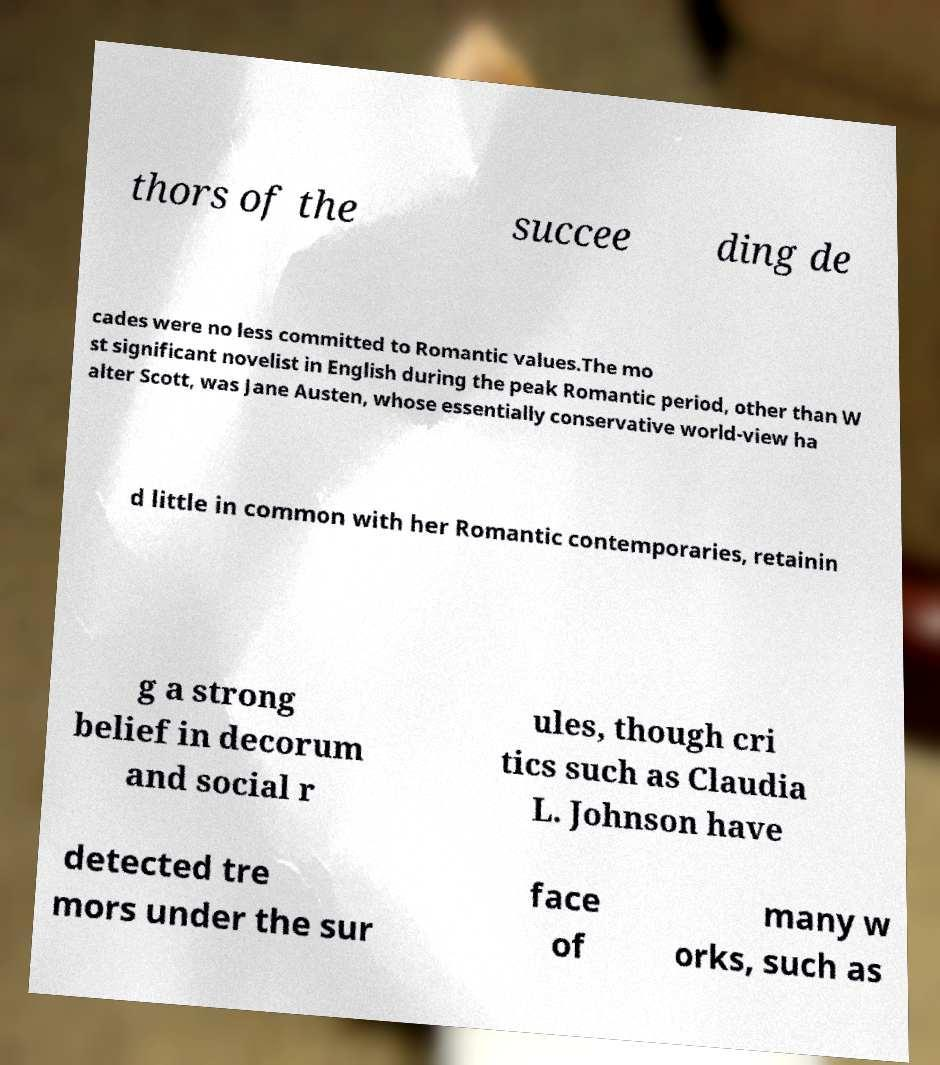There's text embedded in this image that I need extracted. Can you transcribe it verbatim? thors of the succee ding de cades were no less committed to Romantic values.The mo st significant novelist in English during the peak Romantic period, other than W alter Scott, was Jane Austen, whose essentially conservative world-view ha d little in common with her Romantic contemporaries, retainin g a strong belief in decorum and social r ules, though cri tics such as Claudia L. Johnson have detected tre mors under the sur face of many w orks, such as 